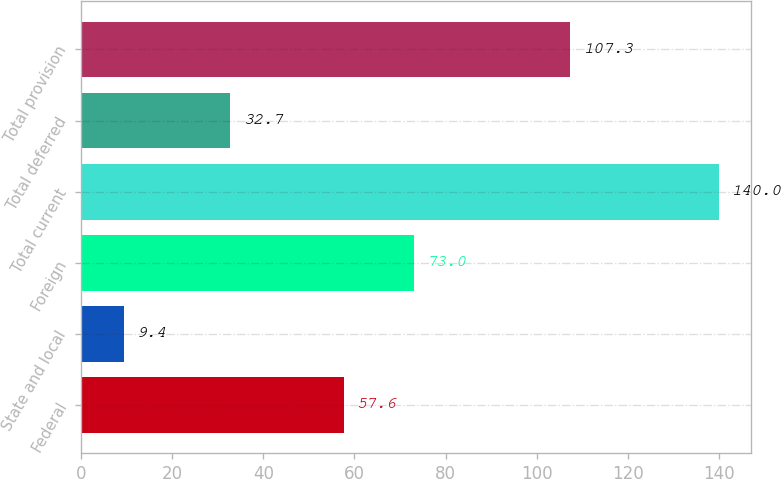Convert chart to OTSL. <chart><loc_0><loc_0><loc_500><loc_500><bar_chart><fcel>Federal<fcel>State and local<fcel>Foreign<fcel>Total current<fcel>Total deferred<fcel>Total provision<nl><fcel>57.6<fcel>9.4<fcel>73<fcel>140<fcel>32.7<fcel>107.3<nl></chart> 